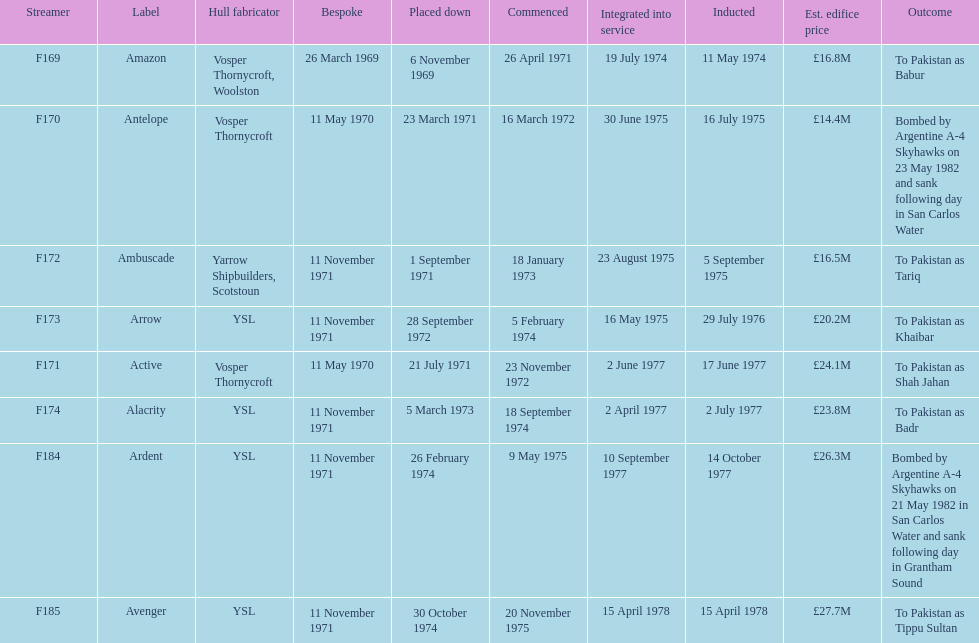How many boats costed less than £20m to build? 3. 